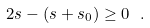<formula> <loc_0><loc_0><loc_500><loc_500>2 s - ( s + s _ { 0 } ) \geq 0 \ .</formula> 